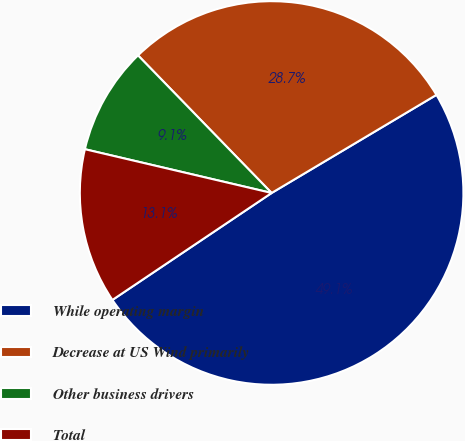<chart> <loc_0><loc_0><loc_500><loc_500><pie_chart><fcel>While operating margin<fcel>Decrease at US Wind primarily<fcel>Other business drivers<fcel>Total<nl><fcel>49.13%<fcel>28.72%<fcel>9.07%<fcel>13.08%<nl></chart> 